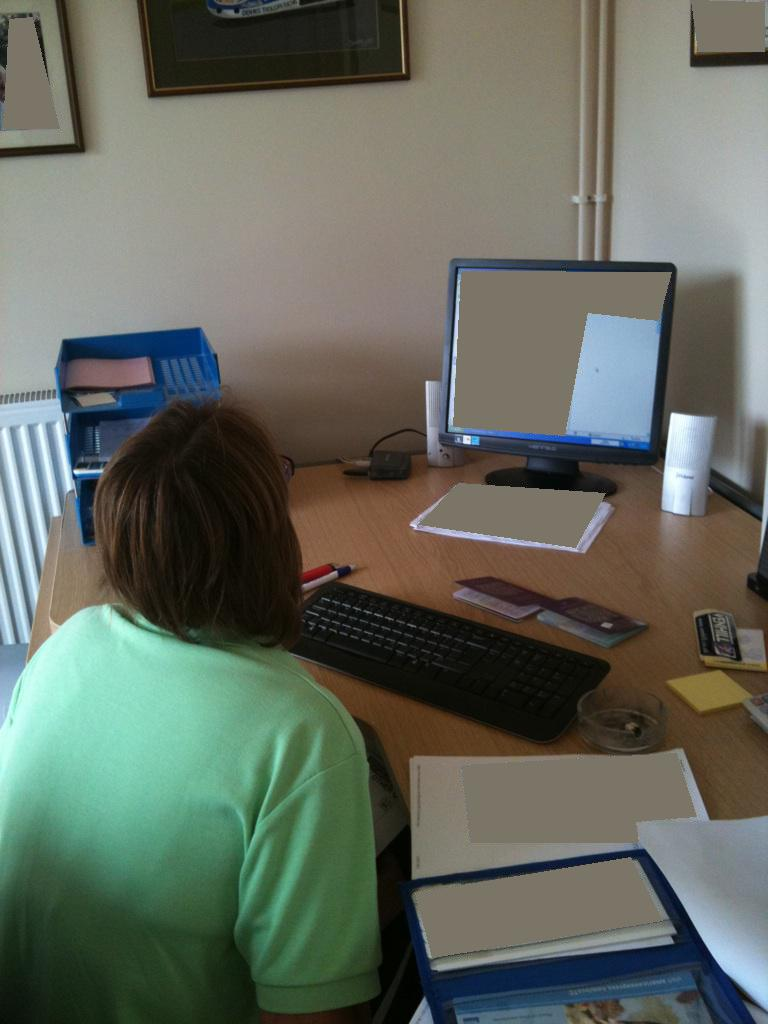What is the person doing? The person is seated at a desk, focusing on a computer screen, likely engaged in typing or viewing content, as indicated by their posture facing the monitor and their hand near the keyboard. 